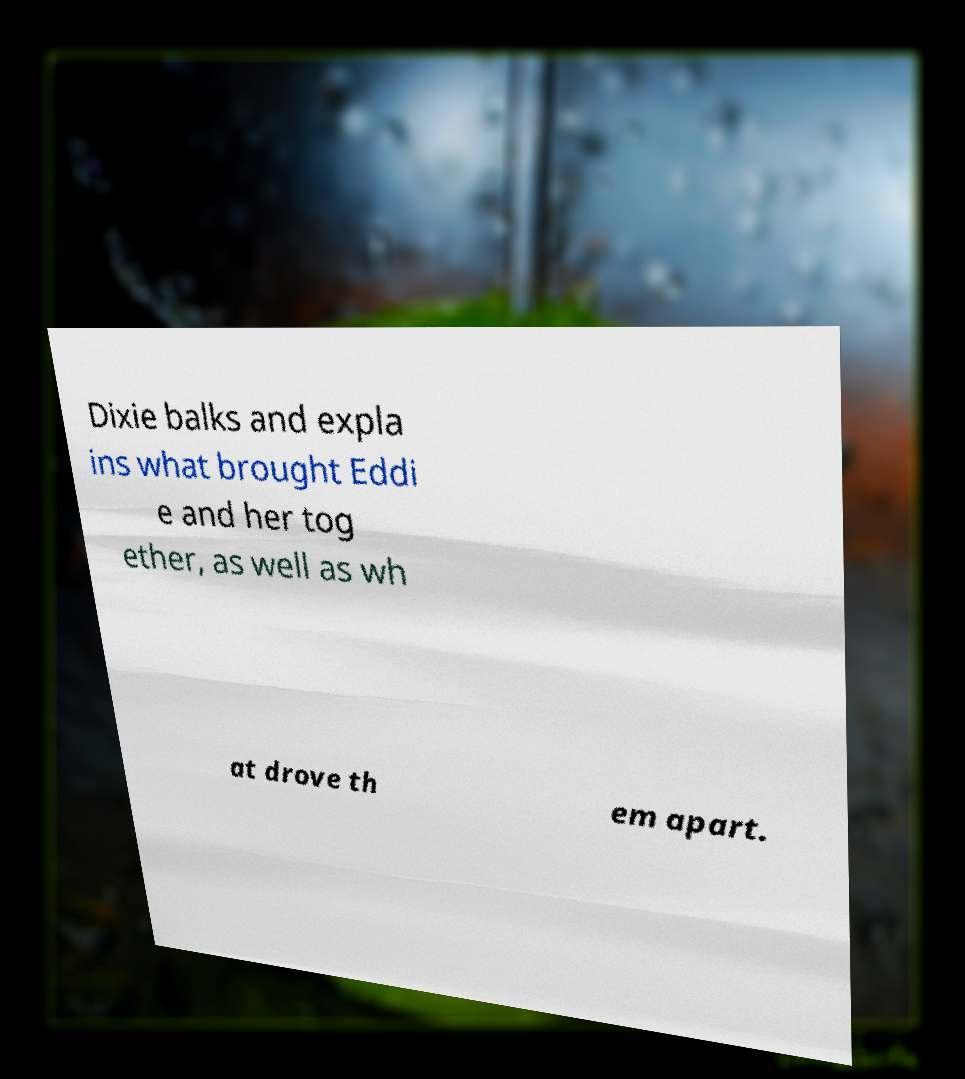I need the written content from this picture converted into text. Can you do that? Dixie balks and expla ins what brought Eddi e and her tog ether, as well as wh at drove th em apart. 